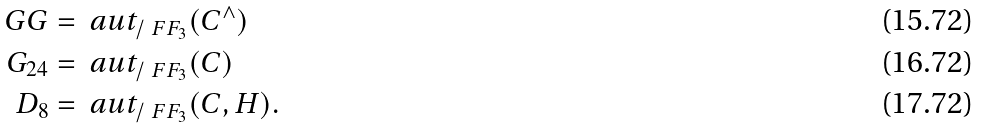Convert formula to latex. <formula><loc_0><loc_0><loc_500><loc_500>\ G G & = \ a u t _ { / \ F F _ { 3 } } ( C ^ { \wedge } ) \\ G _ { 2 4 } & = \ a u t _ { / \ F F _ { 3 } } ( C ) \\ D _ { 8 } & = \ a u t _ { / \ F F _ { 3 } } ( C , H ) .</formula> 